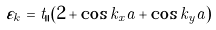<formula> <loc_0><loc_0><loc_500><loc_500>\varepsilon _ { k _ { \| } } = t _ { \| } \left ( 2 + \cos k _ { x } a + \cos k _ { y } a \right )</formula> 